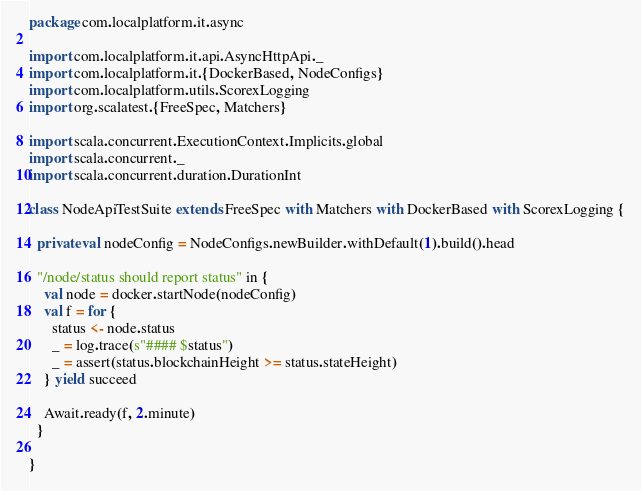<code> <loc_0><loc_0><loc_500><loc_500><_Scala_>package com.localplatform.it.async

import com.localplatform.it.api.AsyncHttpApi._
import com.localplatform.it.{DockerBased, NodeConfigs}
import com.localplatform.utils.ScorexLogging
import org.scalatest.{FreeSpec, Matchers}

import scala.concurrent.ExecutionContext.Implicits.global
import scala.concurrent._
import scala.concurrent.duration.DurationInt

class NodeApiTestSuite extends FreeSpec with Matchers with DockerBased with ScorexLogging {

  private val nodeConfig = NodeConfigs.newBuilder.withDefault(1).build().head

  "/node/status should report status" in {
    val node = docker.startNode(nodeConfig)
    val f = for {
      status <- node.status
      _ = log.trace(s"#### $status")
      _ = assert(status.blockchainHeight >= status.stateHeight)
    } yield succeed

    Await.ready(f, 2.minute)
  }

}
</code> 